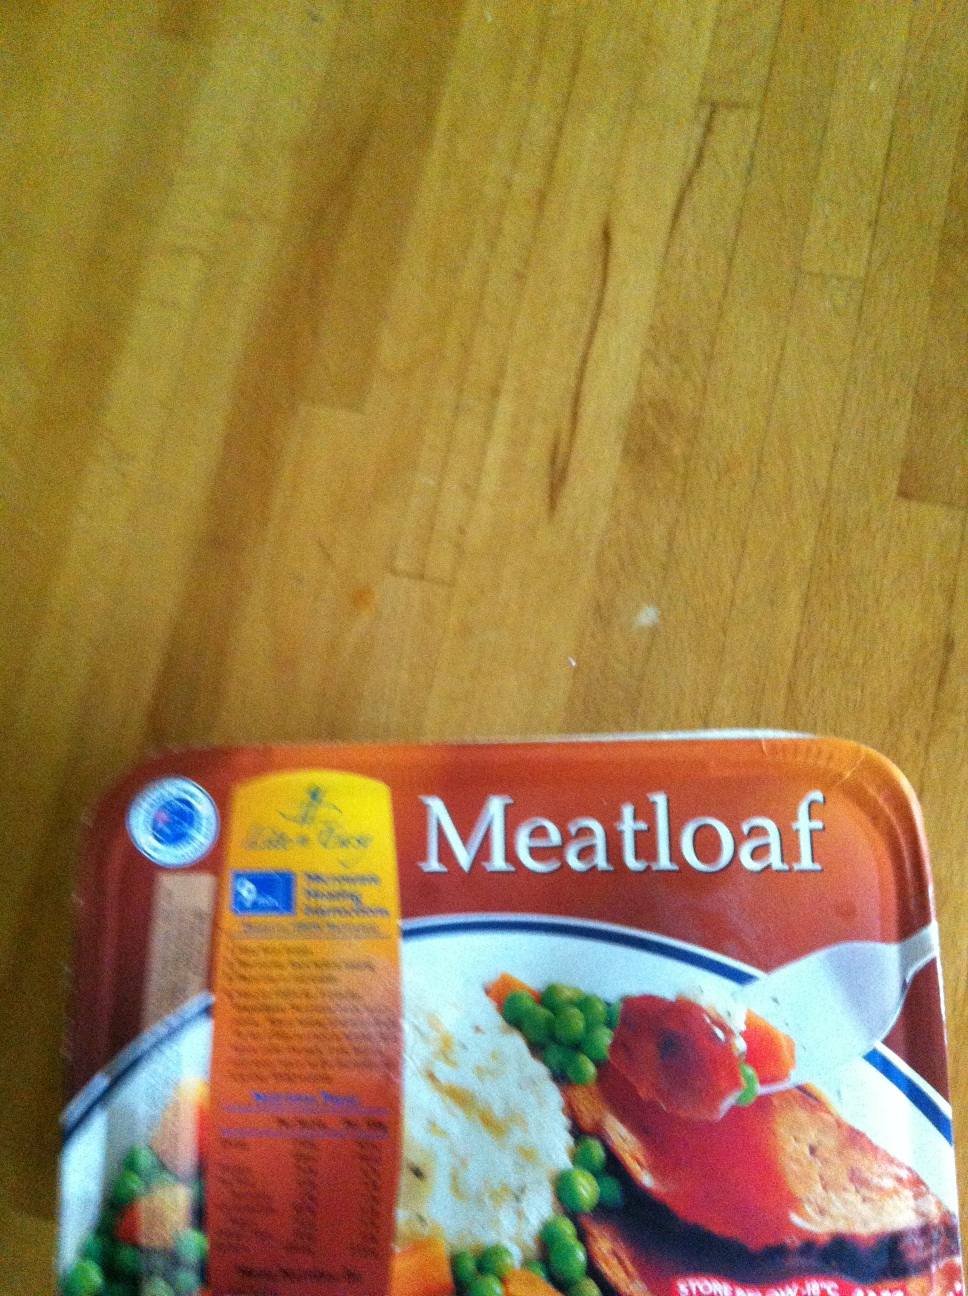What is in this box? The box contains meatloaf, which is usually accompanied by vegetables such as peas and carrots. The packaging indicates it's a ready-to-eat meal, possibly offered by a specific brand known for convenience foods. 